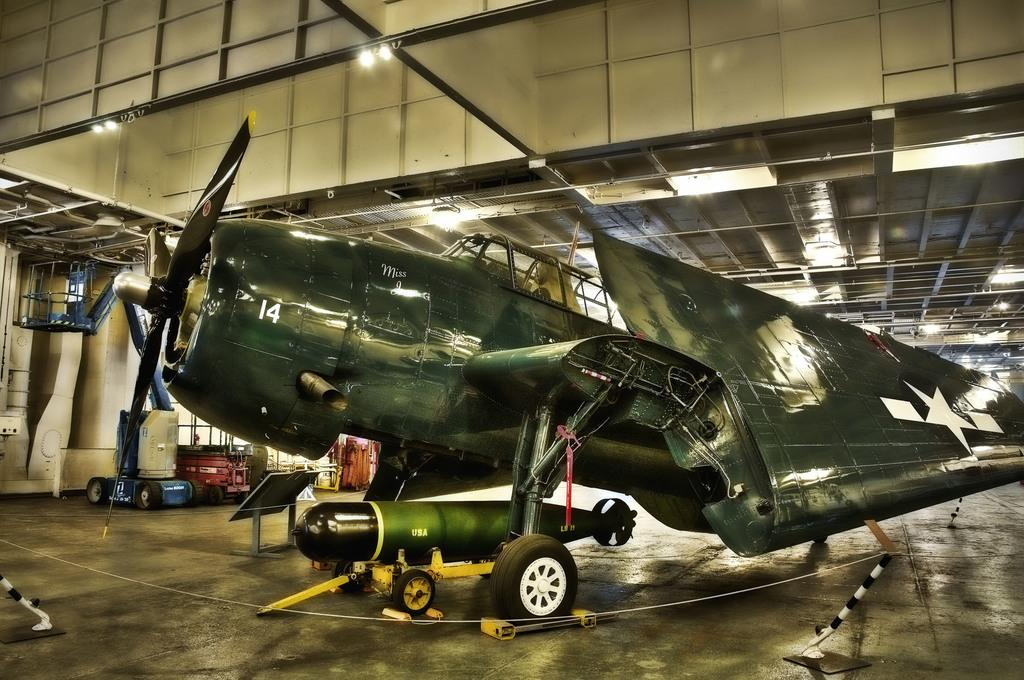What is the main subject of the image? The main subject of the image is a plane. Can you describe the color of the plane? The plane is green in color. What other object can be seen at the bottom of the image? There is a missile at the bottom of the image. Where was the image taken? The image was taken in a hanger. What type of books can be seen in the image? There are no books or a library present in the image. Can you describe the turkey's mouth in the image? There is no turkey present in the image. 